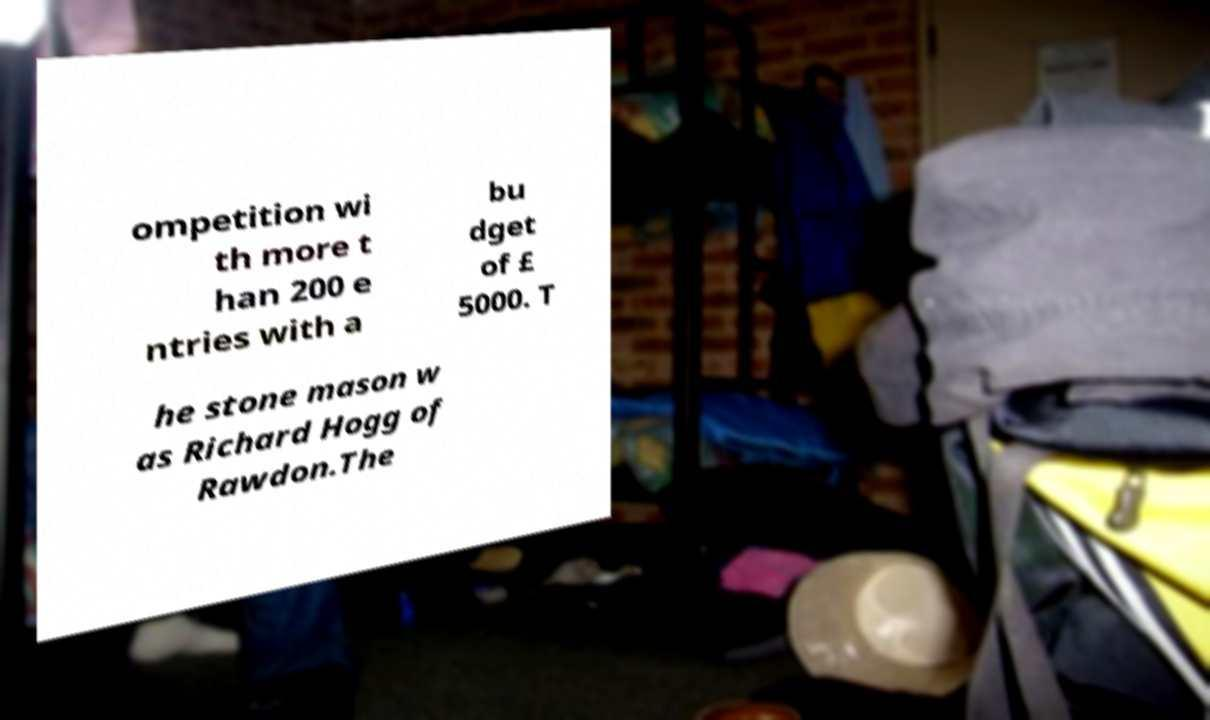Could you assist in decoding the text presented in this image and type it out clearly? ompetition wi th more t han 200 e ntries with a bu dget of £ 5000. T he stone mason w as Richard Hogg of Rawdon.The 